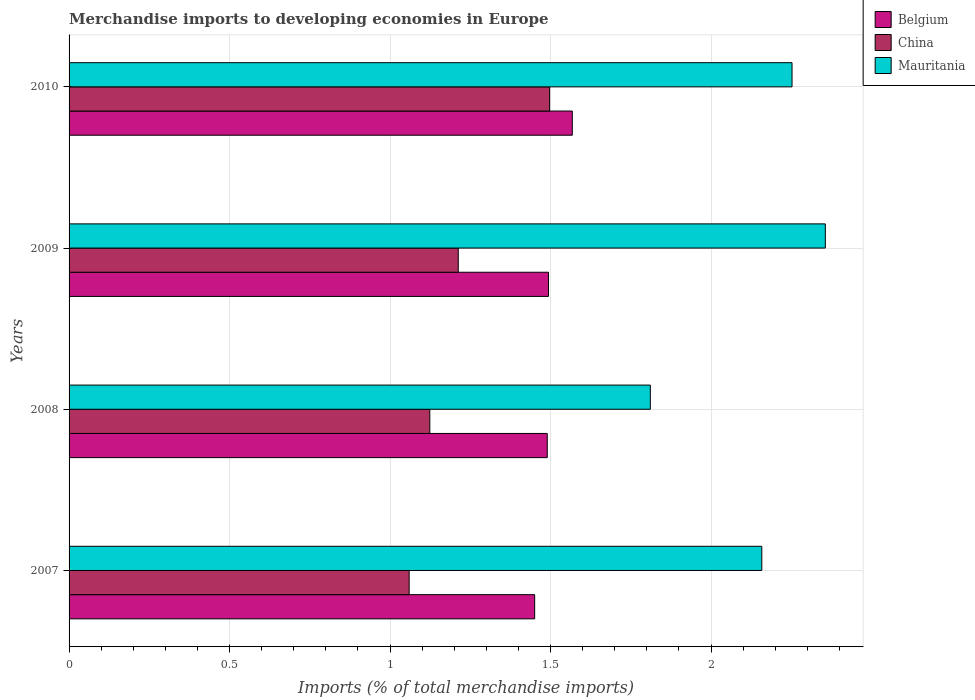How many different coloured bars are there?
Make the answer very short. 3. Are the number of bars on each tick of the Y-axis equal?
Your response must be concise. Yes. How many bars are there on the 2nd tick from the top?
Your answer should be compact. 3. What is the percentage total merchandise imports in Belgium in 2008?
Make the answer very short. 1.49. Across all years, what is the maximum percentage total merchandise imports in China?
Your answer should be compact. 1.5. Across all years, what is the minimum percentage total merchandise imports in Mauritania?
Ensure brevity in your answer.  1.81. What is the total percentage total merchandise imports in China in the graph?
Offer a terse response. 4.89. What is the difference between the percentage total merchandise imports in Mauritania in 2009 and that in 2010?
Ensure brevity in your answer.  0.1. What is the difference between the percentage total merchandise imports in China in 2010 and the percentage total merchandise imports in Belgium in 2009?
Your response must be concise. 0. What is the average percentage total merchandise imports in Belgium per year?
Keep it short and to the point. 1.5. In the year 2007, what is the difference between the percentage total merchandise imports in China and percentage total merchandise imports in Mauritania?
Give a very brief answer. -1.1. In how many years, is the percentage total merchandise imports in China greater than 0.5 %?
Provide a short and direct response. 4. What is the ratio of the percentage total merchandise imports in China in 2008 to that in 2010?
Ensure brevity in your answer.  0.75. Is the percentage total merchandise imports in China in 2007 less than that in 2009?
Make the answer very short. Yes. Is the difference between the percentage total merchandise imports in China in 2007 and 2010 greater than the difference between the percentage total merchandise imports in Mauritania in 2007 and 2010?
Make the answer very short. No. What is the difference between the highest and the second highest percentage total merchandise imports in Belgium?
Your answer should be very brief. 0.07. What is the difference between the highest and the lowest percentage total merchandise imports in Belgium?
Your response must be concise. 0.12. Is it the case that in every year, the sum of the percentage total merchandise imports in Mauritania and percentage total merchandise imports in China is greater than the percentage total merchandise imports in Belgium?
Your answer should be compact. Yes. How many bars are there?
Offer a terse response. 12. Are the values on the major ticks of X-axis written in scientific E-notation?
Provide a short and direct response. No. How are the legend labels stacked?
Offer a terse response. Vertical. What is the title of the graph?
Keep it short and to the point. Merchandise imports to developing economies in Europe. What is the label or title of the X-axis?
Your answer should be very brief. Imports (% of total merchandise imports). What is the label or title of the Y-axis?
Make the answer very short. Years. What is the Imports (% of total merchandise imports) of Belgium in 2007?
Offer a very short reply. 1.45. What is the Imports (% of total merchandise imports) in China in 2007?
Your answer should be compact. 1.06. What is the Imports (% of total merchandise imports) of Mauritania in 2007?
Provide a short and direct response. 2.16. What is the Imports (% of total merchandise imports) in Belgium in 2008?
Make the answer very short. 1.49. What is the Imports (% of total merchandise imports) of China in 2008?
Your answer should be compact. 1.12. What is the Imports (% of total merchandise imports) in Mauritania in 2008?
Your answer should be compact. 1.81. What is the Imports (% of total merchandise imports) of Belgium in 2009?
Offer a very short reply. 1.49. What is the Imports (% of total merchandise imports) in China in 2009?
Ensure brevity in your answer.  1.21. What is the Imports (% of total merchandise imports) in Mauritania in 2009?
Provide a short and direct response. 2.36. What is the Imports (% of total merchandise imports) of Belgium in 2010?
Offer a terse response. 1.57. What is the Imports (% of total merchandise imports) of China in 2010?
Keep it short and to the point. 1.5. What is the Imports (% of total merchandise imports) of Mauritania in 2010?
Ensure brevity in your answer.  2.25. Across all years, what is the maximum Imports (% of total merchandise imports) in Belgium?
Keep it short and to the point. 1.57. Across all years, what is the maximum Imports (% of total merchandise imports) in China?
Provide a succinct answer. 1.5. Across all years, what is the maximum Imports (% of total merchandise imports) of Mauritania?
Offer a terse response. 2.36. Across all years, what is the minimum Imports (% of total merchandise imports) of Belgium?
Your answer should be very brief. 1.45. Across all years, what is the minimum Imports (% of total merchandise imports) in China?
Make the answer very short. 1.06. Across all years, what is the minimum Imports (% of total merchandise imports) of Mauritania?
Your response must be concise. 1.81. What is the total Imports (% of total merchandise imports) in Belgium in the graph?
Ensure brevity in your answer.  6. What is the total Imports (% of total merchandise imports) in China in the graph?
Offer a terse response. 4.89. What is the total Imports (% of total merchandise imports) of Mauritania in the graph?
Ensure brevity in your answer.  8.58. What is the difference between the Imports (% of total merchandise imports) of Belgium in 2007 and that in 2008?
Keep it short and to the point. -0.04. What is the difference between the Imports (% of total merchandise imports) of China in 2007 and that in 2008?
Offer a terse response. -0.06. What is the difference between the Imports (% of total merchandise imports) in Mauritania in 2007 and that in 2008?
Offer a terse response. 0.35. What is the difference between the Imports (% of total merchandise imports) of Belgium in 2007 and that in 2009?
Your answer should be compact. -0.04. What is the difference between the Imports (% of total merchandise imports) in China in 2007 and that in 2009?
Offer a terse response. -0.15. What is the difference between the Imports (% of total merchandise imports) of Mauritania in 2007 and that in 2009?
Ensure brevity in your answer.  -0.2. What is the difference between the Imports (% of total merchandise imports) in Belgium in 2007 and that in 2010?
Ensure brevity in your answer.  -0.12. What is the difference between the Imports (% of total merchandise imports) of China in 2007 and that in 2010?
Offer a terse response. -0.44. What is the difference between the Imports (% of total merchandise imports) in Mauritania in 2007 and that in 2010?
Make the answer very short. -0.09. What is the difference between the Imports (% of total merchandise imports) in Belgium in 2008 and that in 2009?
Provide a succinct answer. -0. What is the difference between the Imports (% of total merchandise imports) of China in 2008 and that in 2009?
Keep it short and to the point. -0.09. What is the difference between the Imports (% of total merchandise imports) of Mauritania in 2008 and that in 2009?
Make the answer very short. -0.55. What is the difference between the Imports (% of total merchandise imports) of Belgium in 2008 and that in 2010?
Your answer should be very brief. -0.08. What is the difference between the Imports (% of total merchandise imports) of China in 2008 and that in 2010?
Provide a short and direct response. -0.37. What is the difference between the Imports (% of total merchandise imports) in Mauritania in 2008 and that in 2010?
Your response must be concise. -0.44. What is the difference between the Imports (% of total merchandise imports) in Belgium in 2009 and that in 2010?
Offer a very short reply. -0.07. What is the difference between the Imports (% of total merchandise imports) of China in 2009 and that in 2010?
Keep it short and to the point. -0.28. What is the difference between the Imports (% of total merchandise imports) in Mauritania in 2009 and that in 2010?
Your answer should be very brief. 0.1. What is the difference between the Imports (% of total merchandise imports) in Belgium in 2007 and the Imports (% of total merchandise imports) in China in 2008?
Provide a short and direct response. 0.33. What is the difference between the Imports (% of total merchandise imports) of Belgium in 2007 and the Imports (% of total merchandise imports) of Mauritania in 2008?
Make the answer very short. -0.36. What is the difference between the Imports (% of total merchandise imports) of China in 2007 and the Imports (% of total merchandise imports) of Mauritania in 2008?
Your answer should be compact. -0.75. What is the difference between the Imports (% of total merchandise imports) in Belgium in 2007 and the Imports (% of total merchandise imports) in China in 2009?
Keep it short and to the point. 0.24. What is the difference between the Imports (% of total merchandise imports) in Belgium in 2007 and the Imports (% of total merchandise imports) in Mauritania in 2009?
Keep it short and to the point. -0.91. What is the difference between the Imports (% of total merchandise imports) in China in 2007 and the Imports (% of total merchandise imports) in Mauritania in 2009?
Ensure brevity in your answer.  -1.3. What is the difference between the Imports (% of total merchandise imports) in Belgium in 2007 and the Imports (% of total merchandise imports) in China in 2010?
Ensure brevity in your answer.  -0.05. What is the difference between the Imports (% of total merchandise imports) in Belgium in 2007 and the Imports (% of total merchandise imports) in Mauritania in 2010?
Offer a very short reply. -0.8. What is the difference between the Imports (% of total merchandise imports) of China in 2007 and the Imports (% of total merchandise imports) of Mauritania in 2010?
Your answer should be very brief. -1.19. What is the difference between the Imports (% of total merchandise imports) in Belgium in 2008 and the Imports (% of total merchandise imports) in China in 2009?
Provide a short and direct response. 0.28. What is the difference between the Imports (% of total merchandise imports) in Belgium in 2008 and the Imports (% of total merchandise imports) in Mauritania in 2009?
Provide a succinct answer. -0.87. What is the difference between the Imports (% of total merchandise imports) in China in 2008 and the Imports (% of total merchandise imports) in Mauritania in 2009?
Ensure brevity in your answer.  -1.23. What is the difference between the Imports (% of total merchandise imports) of Belgium in 2008 and the Imports (% of total merchandise imports) of China in 2010?
Keep it short and to the point. -0.01. What is the difference between the Imports (% of total merchandise imports) in Belgium in 2008 and the Imports (% of total merchandise imports) in Mauritania in 2010?
Provide a short and direct response. -0.76. What is the difference between the Imports (% of total merchandise imports) in China in 2008 and the Imports (% of total merchandise imports) in Mauritania in 2010?
Make the answer very short. -1.13. What is the difference between the Imports (% of total merchandise imports) of Belgium in 2009 and the Imports (% of total merchandise imports) of China in 2010?
Give a very brief answer. -0. What is the difference between the Imports (% of total merchandise imports) in Belgium in 2009 and the Imports (% of total merchandise imports) in Mauritania in 2010?
Your answer should be very brief. -0.76. What is the difference between the Imports (% of total merchandise imports) in China in 2009 and the Imports (% of total merchandise imports) in Mauritania in 2010?
Provide a succinct answer. -1.04. What is the average Imports (% of total merchandise imports) of Belgium per year?
Offer a terse response. 1.5. What is the average Imports (% of total merchandise imports) in China per year?
Offer a terse response. 1.22. What is the average Imports (% of total merchandise imports) of Mauritania per year?
Provide a short and direct response. 2.14. In the year 2007, what is the difference between the Imports (% of total merchandise imports) of Belgium and Imports (% of total merchandise imports) of China?
Your answer should be very brief. 0.39. In the year 2007, what is the difference between the Imports (% of total merchandise imports) in Belgium and Imports (% of total merchandise imports) in Mauritania?
Make the answer very short. -0.71. In the year 2007, what is the difference between the Imports (% of total merchandise imports) of China and Imports (% of total merchandise imports) of Mauritania?
Offer a very short reply. -1.1. In the year 2008, what is the difference between the Imports (% of total merchandise imports) in Belgium and Imports (% of total merchandise imports) in China?
Ensure brevity in your answer.  0.37. In the year 2008, what is the difference between the Imports (% of total merchandise imports) of Belgium and Imports (% of total merchandise imports) of Mauritania?
Give a very brief answer. -0.32. In the year 2008, what is the difference between the Imports (% of total merchandise imports) in China and Imports (% of total merchandise imports) in Mauritania?
Provide a short and direct response. -0.69. In the year 2009, what is the difference between the Imports (% of total merchandise imports) in Belgium and Imports (% of total merchandise imports) in China?
Make the answer very short. 0.28. In the year 2009, what is the difference between the Imports (% of total merchandise imports) in Belgium and Imports (% of total merchandise imports) in Mauritania?
Offer a very short reply. -0.86. In the year 2009, what is the difference between the Imports (% of total merchandise imports) of China and Imports (% of total merchandise imports) of Mauritania?
Your answer should be compact. -1.14. In the year 2010, what is the difference between the Imports (% of total merchandise imports) in Belgium and Imports (% of total merchandise imports) in China?
Your answer should be very brief. 0.07. In the year 2010, what is the difference between the Imports (% of total merchandise imports) in Belgium and Imports (% of total merchandise imports) in Mauritania?
Offer a very short reply. -0.68. In the year 2010, what is the difference between the Imports (% of total merchandise imports) in China and Imports (% of total merchandise imports) in Mauritania?
Give a very brief answer. -0.76. What is the ratio of the Imports (% of total merchandise imports) in Belgium in 2007 to that in 2008?
Provide a succinct answer. 0.97. What is the ratio of the Imports (% of total merchandise imports) in China in 2007 to that in 2008?
Give a very brief answer. 0.94. What is the ratio of the Imports (% of total merchandise imports) of Mauritania in 2007 to that in 2008?
Ensure brevity in your answer.  1.19. What is the ratio of the Imports (% of total merchandise imports) of Belgium in 2007 to that in 2009?
Offer a very short reply. 0.97. What is the ratio of the Imports (% of total merchandise imports) of China in 2007 to that in 2009?
Offer a terse response. 0.87. What is the ratio of the Imports (% of total merchandise imports) of Mauritania in 2007 to that in 2009?
Keep it short and to the point. 0.92. What is the ratio of the Imports (% of total merchandise imports) in Belgium in 2007 to that in 2010?
Provide a short and direct response. 0.93. What is the ratio of the Imports (% of total merchandise imports) of China in 2007 to that in 2010?
Provide a succinct answer. 0.71. What is the ratio of the Imports (% of total merchandise imports) of Mauritania in 2007 to that in 2010?
Make the answer very short. 0.96. What is the ratio of the Imports (% of total merchandise imports) in Belgium in 2008 to that in 2009?
Your answer should be compact. 1. What is the ratio of the Imports (% of total merchandise imports) of China in 2008 to that in 2009?
Your answer should be very brief. 0.93. What is the ratio of the Imports (% of total merchandise imports) in Mauritania in 2008 to that in 2009?
Provide a succinct answer. 0.77. What is the ratio of the Imports (% of total merchandise imports) in Belgium in 2008 to that in 2010?
Give a very brief answer. 0.95. What is the ratio of the Imports (% of total merchandise imports) in China in 2008 to that in 2010?
Provide a short and direct response. 0.75. What is the ratio of the Imports (% of total merchandise imports) of Mauritania in 2008 to that in 2010?
Ensure brevity in your answer.  0.8. What is the ratio of the Imports (% of total merchandise imports) in Belgium in 2009 to that in 2010?
Give a very brief answer. 0.95. What is the ratio of the Imports (% of total merchandise imports) of China in 2009 to that in 2010?
Make the answer very short. 0.81. What is the ratio of the Imports (% of total merchandise imports) in Mauritania in 2009 to that in 2010?
Keep it short and to the point. 1.05. What is the difference between the highest and the second highest Imports (% of total merchandise imports) of Belgium?
Your answer should be compact. 0.07. What is the difference between the highest and the second highest Imports (% of total merchandise imports) of China?
Ensure brevity in your answer.  0.28. What is the difference between the highest and the second highest Imports (% of total merchandise imports) in Mauritania?
Ensure brevity in your answer.  0.1. What is the difference between the highest and the lowest Imports (% of total merchandise imports) of Belgium?
Offer a terse response. 0.12. What is the difference between the highest and the lowest Imports (% of total merchandise imports) of China?
Provide a short and direct response. 0.44. What is the difference between the highest and the lowest Imports (% of total merchandise imports) in Mauritania?
Your answer should be compact. 0.55. 